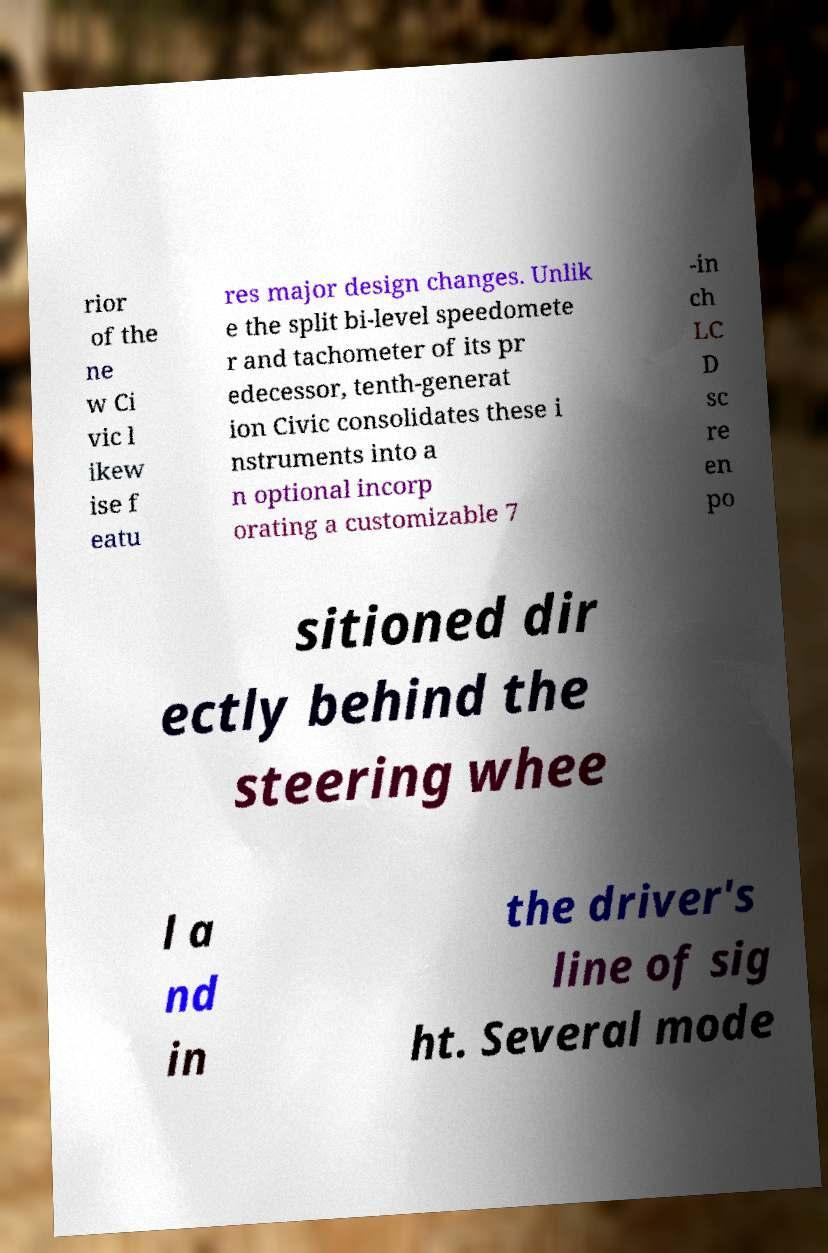Please read and relay the text visible in this image. What does it say? rior of the ne w Ci vic l ikew ise f eatu res major design changes. Unlik e the split bi-level speedomete r and tachometer of its pr edecessor, tenth-generat ion Civic consolidates these i nstruments into a n optional incorp orating a customizable 7 -in ch LC D sc re en po sitioned dir ectly behind the steering whee l a nd in the driver's line of sig ht. Several mode 